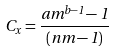<formula> <loc_0><loc_0><loc_500><loc_500>C _ { x } = \frac { a m ^ { b - 1 } - 1 } { ( n m - 1 ) }</formula> 